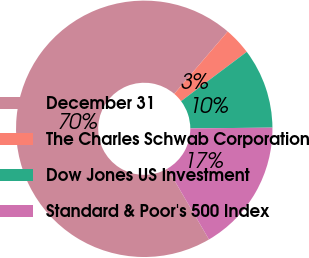<chart> <loc_0><loc_0><loc_500><loc_500><pie_chart><fcel>December 31<fcel>The Charles Schwab Corporation<fcel>Dow Jones US Investment<fcel>Standard & Poor's 500 Index<nl><fcel>69.71%<fcel>3.47%<fcel>10.1%<fcel>16.72%<nl></chart> 